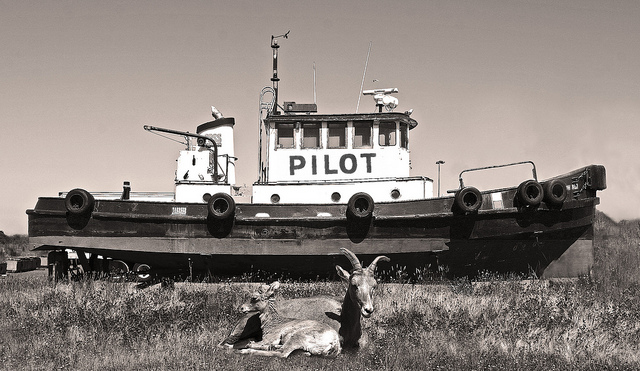Extract all visible text content from this image. PILOT 